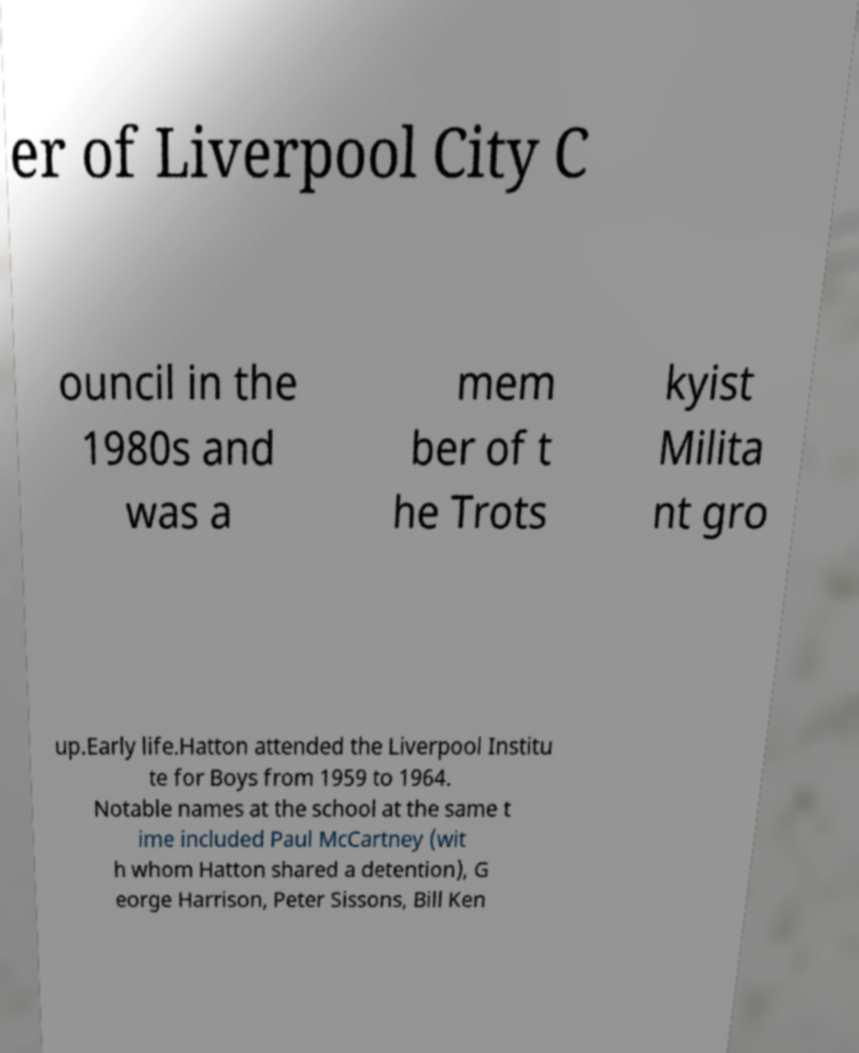Can you read and provide the text displayed in the image?This photo seems to have some interesting text. Can you extract and type it out for me? er of Liverpool City C ouncil in the 1980s and was a mem ber of t he Trots kyist Milita nt gro up.Early life.Hatton attended the Liverpool Institu te for Boys from 1959 to 1964. Notable names at the school at the same t ime included Paul McCartney (wit h whom Hatton shared a detention), G eorge Harrison, Peter Sissons, Bill Ken 